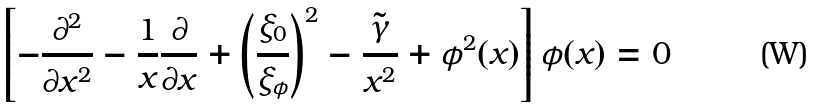<formula> <loc_0><loc_0><loc_500><loc_500>\left [ - \frac { \partial ^ { 2 } } { \partial x ^ { 2 } } - \frac { 1 } { x } \frac { \partial } { \partial x } + \left ( \frac { \xi _ { 0 } } { \xi _ { \phi } } \right ) ^ { 2 } - \frac { \tilde { \gamma } } { x ^ { 2 } } + \phi ^ { 2 } ( x ) \right ] \phi ( x ) = 0</formula> 